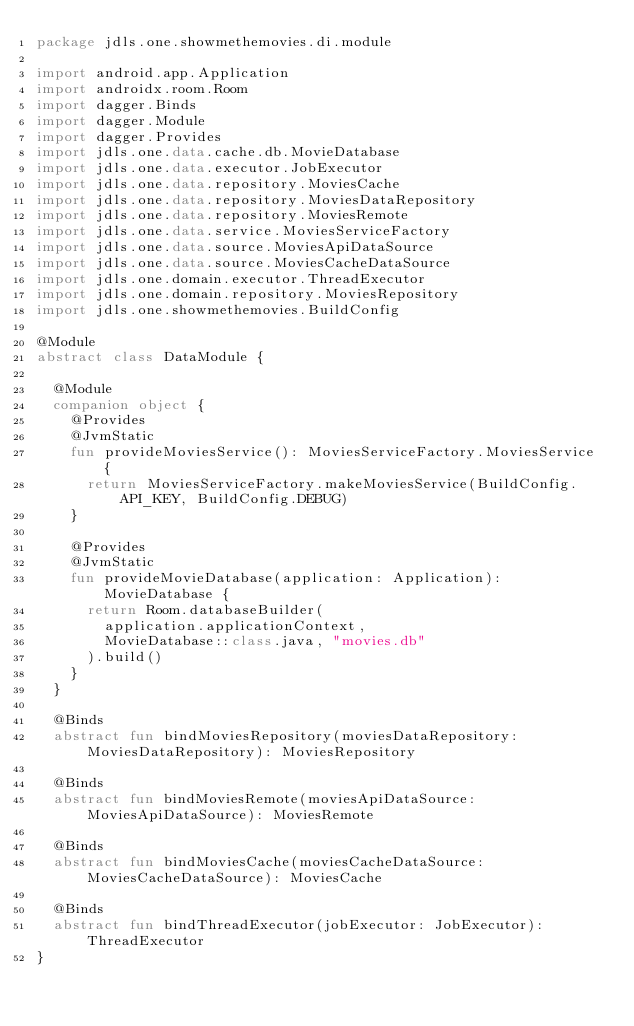<code> <loc_0><loc_0><loc_500><loc_500><_Kotlin_>package jdls.one.showmethemovies.di.module

import android.app.Application
import androidx.room.Room
import dagger.Binds
import dagger.Module
import dagger.Provides
import jdls.one.data.cache.db.MovieDatabase
import jdls.one.data.executor.JobExecutor
import jdls.one.data.repository.MoviesCache
import jdls.one.data.repository.MoviesDataRepository
import jdls.one.data.repository.MoviesRemote
import jdls.one.data.service.MoviesServiceFactory
import jdls.one.data.source.MoviesApiDataSource
import jdls.one.data.source.MoviesCacheDataSource
import jdls.one.domain.executor.ThreadExecutor
import jdls.one.domain.repository.MoviesRepository
import jdls.one.showmethemovies.BuildConfig

@Module
abstract class DataModule {

  @Module
  companion object {
    @Provides
    @JvmStatic
    fun provideMoviesService(): MoviesServiceFactory.MoviesService {
      return MoviesServiceFactory.makeMoviesService(BuildConfig.API_KEY, BuildConfig.DEBUG)
    }

    @Provides
    @JvmStatic
    fun provideMovieDatabase(application: Application): MovieDatabase {
      return Room.databaseBuilder(
        application.applicationContext,
        MovieDatabase::class.java, "movies.db"
      ).build()
    }
  }

  @Binds
  abstract fun bindMoviesRepository(moviesDataRepository: MoviesDataRepository): MoviesRepository

  @Binds
  abstract fun bindMoviesRemote(moviesApiDataSource: MoviesApiDataSource): MoviesRemote

  @Binds
  abstract fun bindMoviesCache(moviesCacheDataSource: MoviesCacheDataSource): MoviesCache

  @Binds
  abstract fun bindThreadExecutor(jobExecutor: JobExecutor): ThreadExecutor
}</code> 